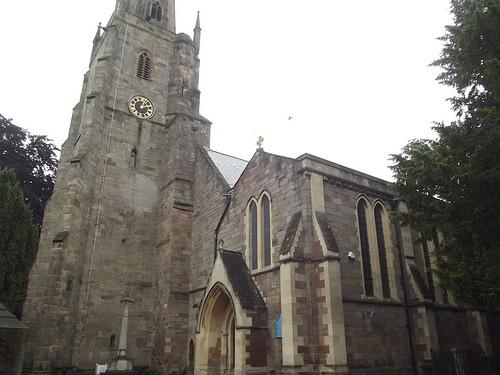<image>
Is there a tree behind the building? No. The tree is not behind the building. From this viewpoint, the tree appears to be positioned elsewhere in the scene. 